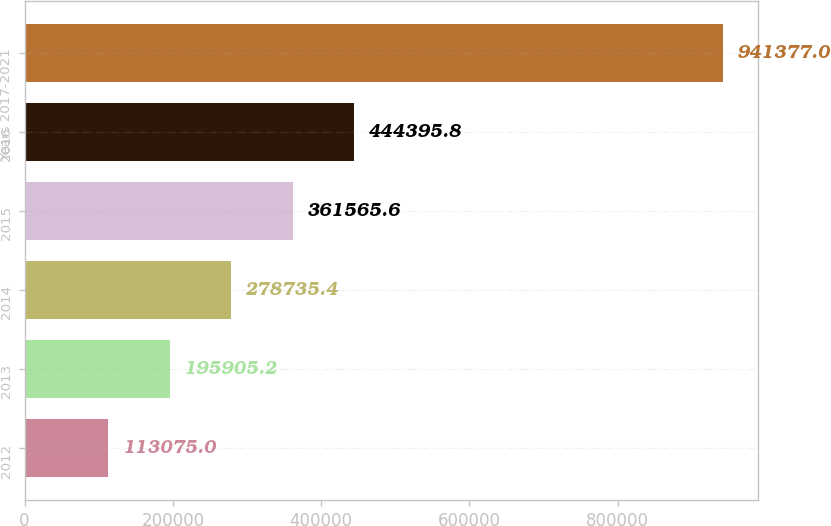Convert chart. <chart><loc_0><loc_0><loc_500><loc_500><bar_chart><fcel>2012<fcel>2013<fcel>2014<fcel>2015<fcel>2016<fcel>Years 2017-2021<nl><fcel>113075<fcel>195905<fcel>278735<fcel>361566<fcel>444396<fcel>941377<nl></chart> 